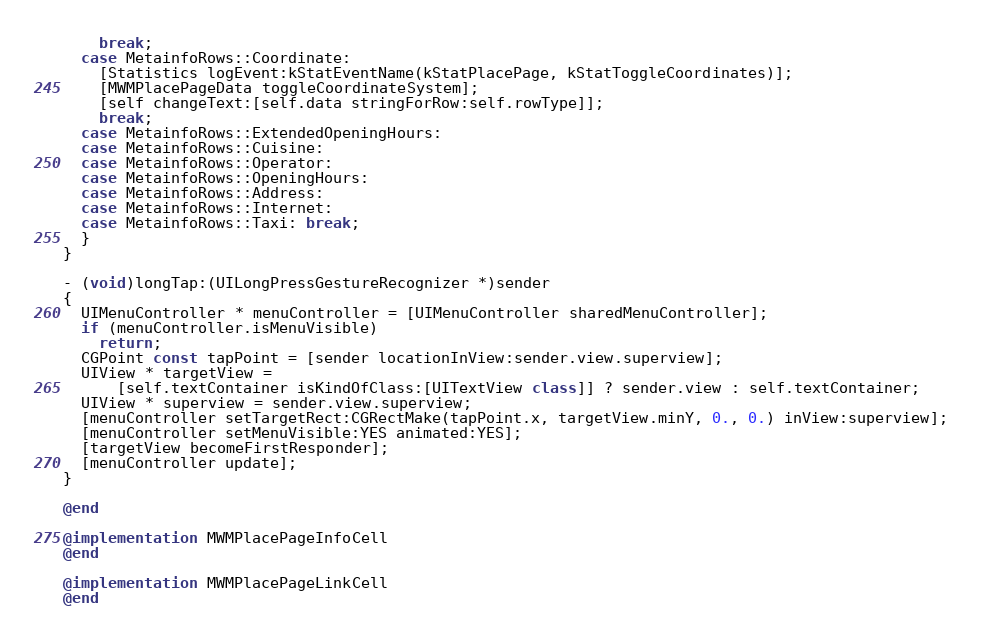Convert code to text. <code><loc_0><loc_0><loc_500><loc_500><_ObjectiveC_>    break;
  case MetainfoRows::Coordinate:
    [Statistics logEvent:kStatEventName(kStatPlacePage, kStatToggleCoordinates)];
    [MWMPlacePageData toggleCoordinateSystem];
    [self changeText:[self.data stringForRow:self.rowType]];
    break;
  case MetainfoRows::ExtendedOpeningHours:
  case MetainfoRows::Cuisine:
  case MetainfoRows::Operator:
  case MetainfoRows::OpeningHours:
  case MetainfoRows::Address:
  case MetainfoRows::Internet:
  case MetainfoRows::Taxi: break;
  }
}

- (void)longTap:(UILongPressGestureRecognizer *)sender
{
  UIMenuController * menuController = [UIMenuController sharedMenuController];
  if (menuController.isMenuVisible)
    return;
  CGPoint const tapPoint = [sender locationInView:sender.view.superview];
  UIView * targetView =
      [self.textContainer isKindOfClass:[UITextView class]] ? sender.view : self.textContainer;
  UIView * superview = sender.view.superview;
  [menuController setTargetRect:CGRectMake(tapPoint.x, targetView.minY, 0., 0.) inView:superview];
  [menuController setMenuVisible:YES animated:YES];
  [targetView becomeFirstResponder];
  [menuController update];
}

@end

@implementation MWMPlacePageInfoCell
@end

@implementation MWMPlacePageLinkCell
@end
</code> 